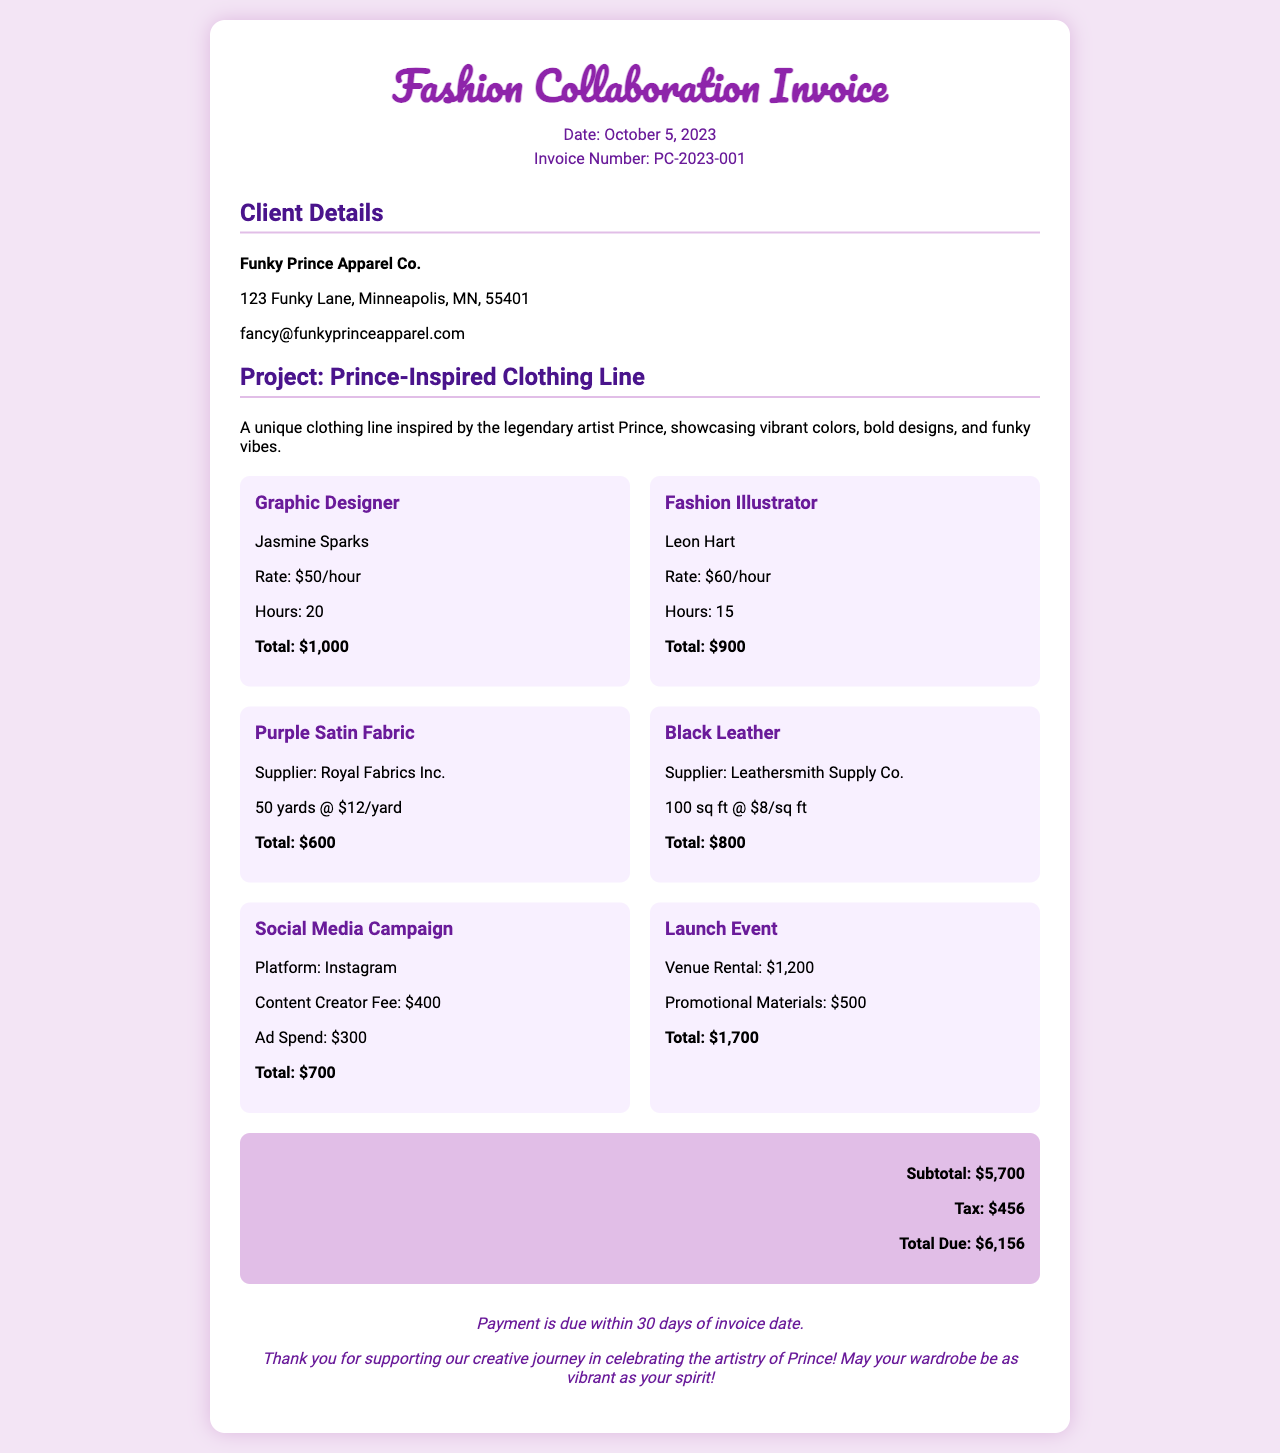what is the date of the invoice? The date of the invoice is mentioned in the header section of the document, which states October 5, 2023.
Answer: October 5, 2023 who is the client for this invoice? The client details section specifies the name of the company as Funky Prince Apparel Co.
Answer: Funky Prince Apparel Co what is the total due amount? The grand total section indicates the total amount due is $6,156.
Answer: $6,156 how many hours did the graphic designer work? The cost breakdown lists the graphic designer’s hours as 20 hours in their respective section.
Answer: 20 what is the total cost of the black leather? The breakdown for black leather shows a total cost of $800.
Answer: $800 what is the purpose of the 'Launch Event' in the promotional expenses? The promotional expenses section outlines the venue rental and promotional materials for the launch event, which is part of the marketing strategy.
Answer: Launch Event how much was spent on the social media campaign? The promotional expenses specify a total of $700 for the social media campaign.
Answer: $700 who is responsible for the fashion illustrations? The cost breakdown section credits Leon Hart as the fashion illustrator.
Answer: Leon Hart what is included in the subtotal? The subtotal includes the sum of the costs from design services, fabric purchases, and promotional expenses, totaling $5,700.
Answer: $5,700 